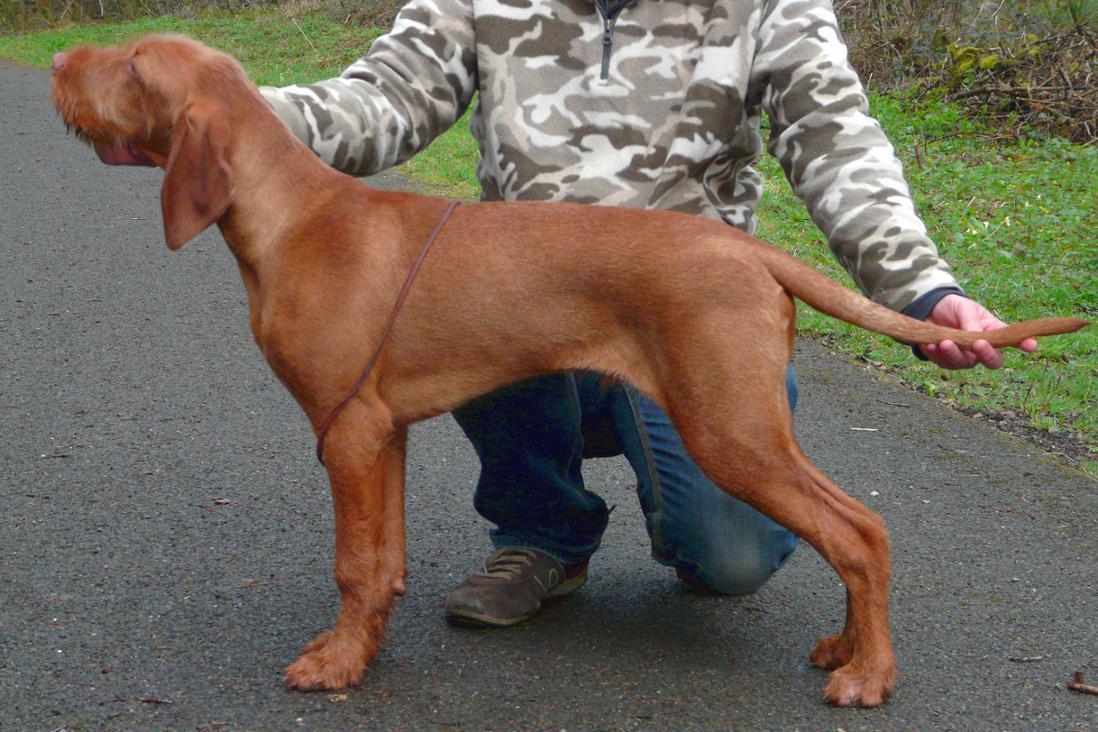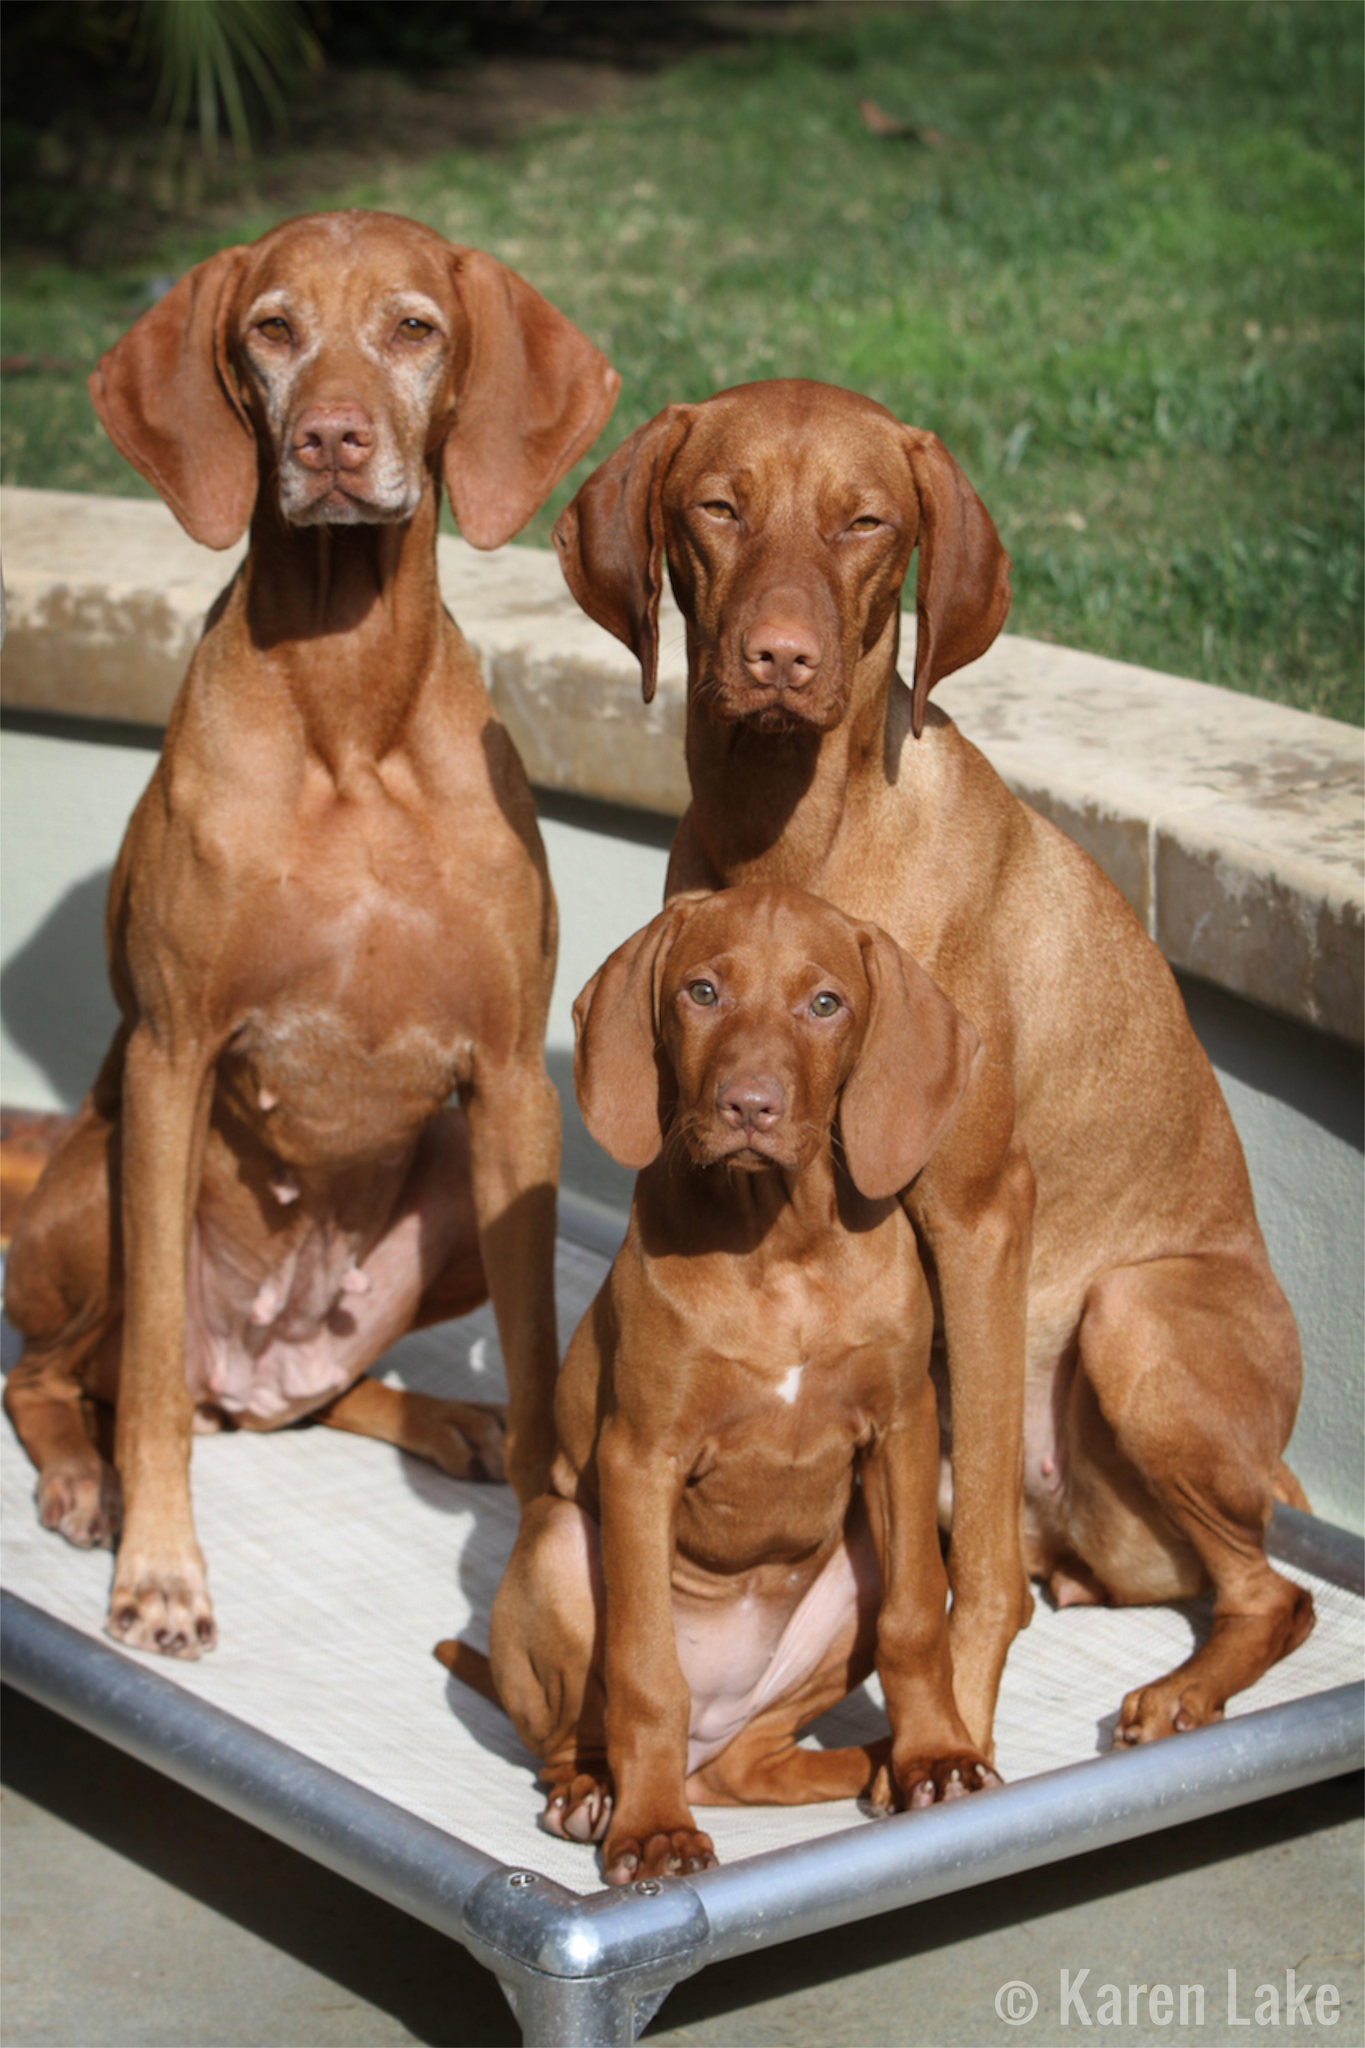The first image is the image on the left, the second image is the image on the right. For the images displayed, is the sentence "At least two dogs are outside." factually correct? Answer yes or no. Yes. The first image is the image on the left, the second image is the image on the right. For the images shown, is this caption "One image shows a rightward-turned dog standing in profile with his tail out straight, and the other image features one puppy in a non-standing pose." true? Answer yes or no. No. 